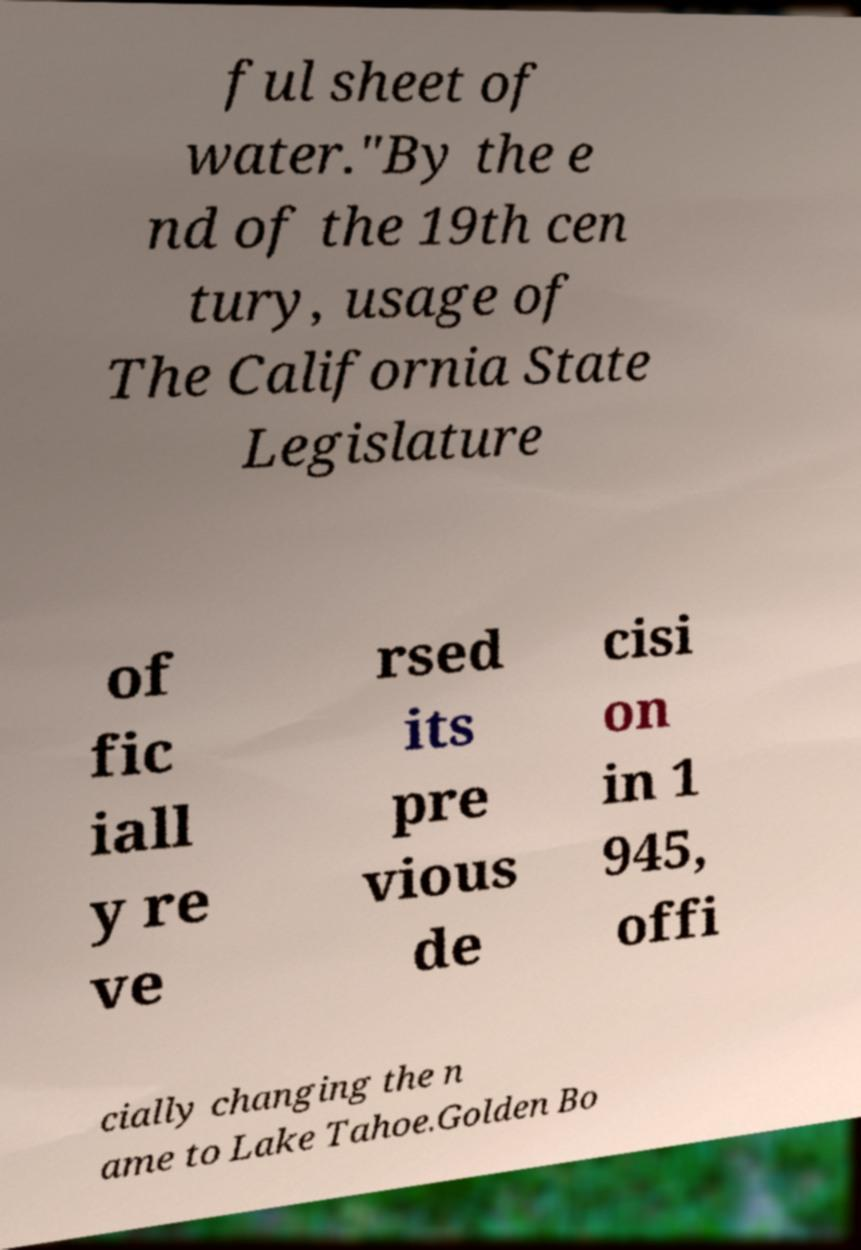Please read and relay the text visible in this image. What does it say? ful sheet of water."By the e nd of the 19th cen tury, usage of The California State Legislature of fic iall y re ve rsed its pre vious de cisi on in 1 945, offi cially changing the n ame to Lake Tahoe.Golden Bo 